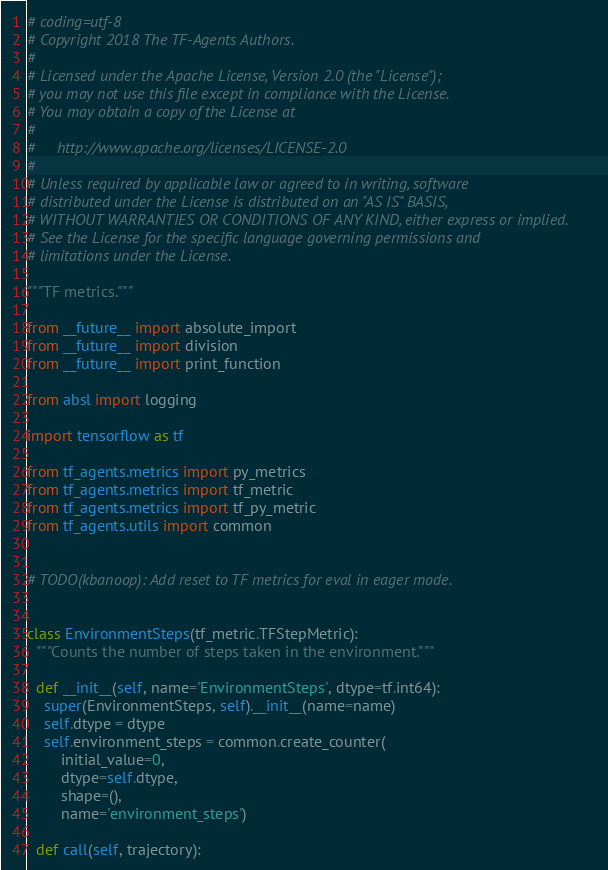Convert code to text. <code><loc_0><loc_0><loc_500><loc_500><_Python_># coding=utf-8
# Copyright 2018 The TF-Agents Authors.
#
# Licensed under the Apache License, Version 2.0 (the "License");
# you may not use this file except in compliance with the License.
# You may obtain a copy of the License at
#
#     http://www.apache.org/licenses/LICENSE-2.0
#
# Unless required by applicable law or agreed to in writing, software
# distributed under the License is distributed on an "AS IS" BASIS,
# WITHOUT WARRANTIES OR CONDITIONS OF ANY KIND, either express or implied.
# See the License for the specific language governing permissions and
# limitations under the License.

"""TF metrics."""

from __future__ import absolute_import
from __future__ import division
from __future__ import print_function

from absl import logging

import tensorflow as tf

from tf_agents.metrics import py_metrics
from tf_agents.metrics import tf_metric
from tf_agents.metrics import tf_py_metric
from tf_agents.utils import common


# TODO(kbanoop): Add reset to TF metrics for eval in eager mode.


class EnvironmentSteps(tf_metric.TFStepMetric):
  """Counts the number of steps taken in the environment."""

  def __init__(self, name='EnvironmentSteps', dtype=tf.int64):
    super(EnvironmentSteps, self).__init__(name=name)
    self.dtype = dtype
    self.environment_steps = common.create_counter(
        initial_value=0,
        dtype=self.dtype,
        shape=(),
        name='environment_steps')

  def call(self, trajectory):</code> 